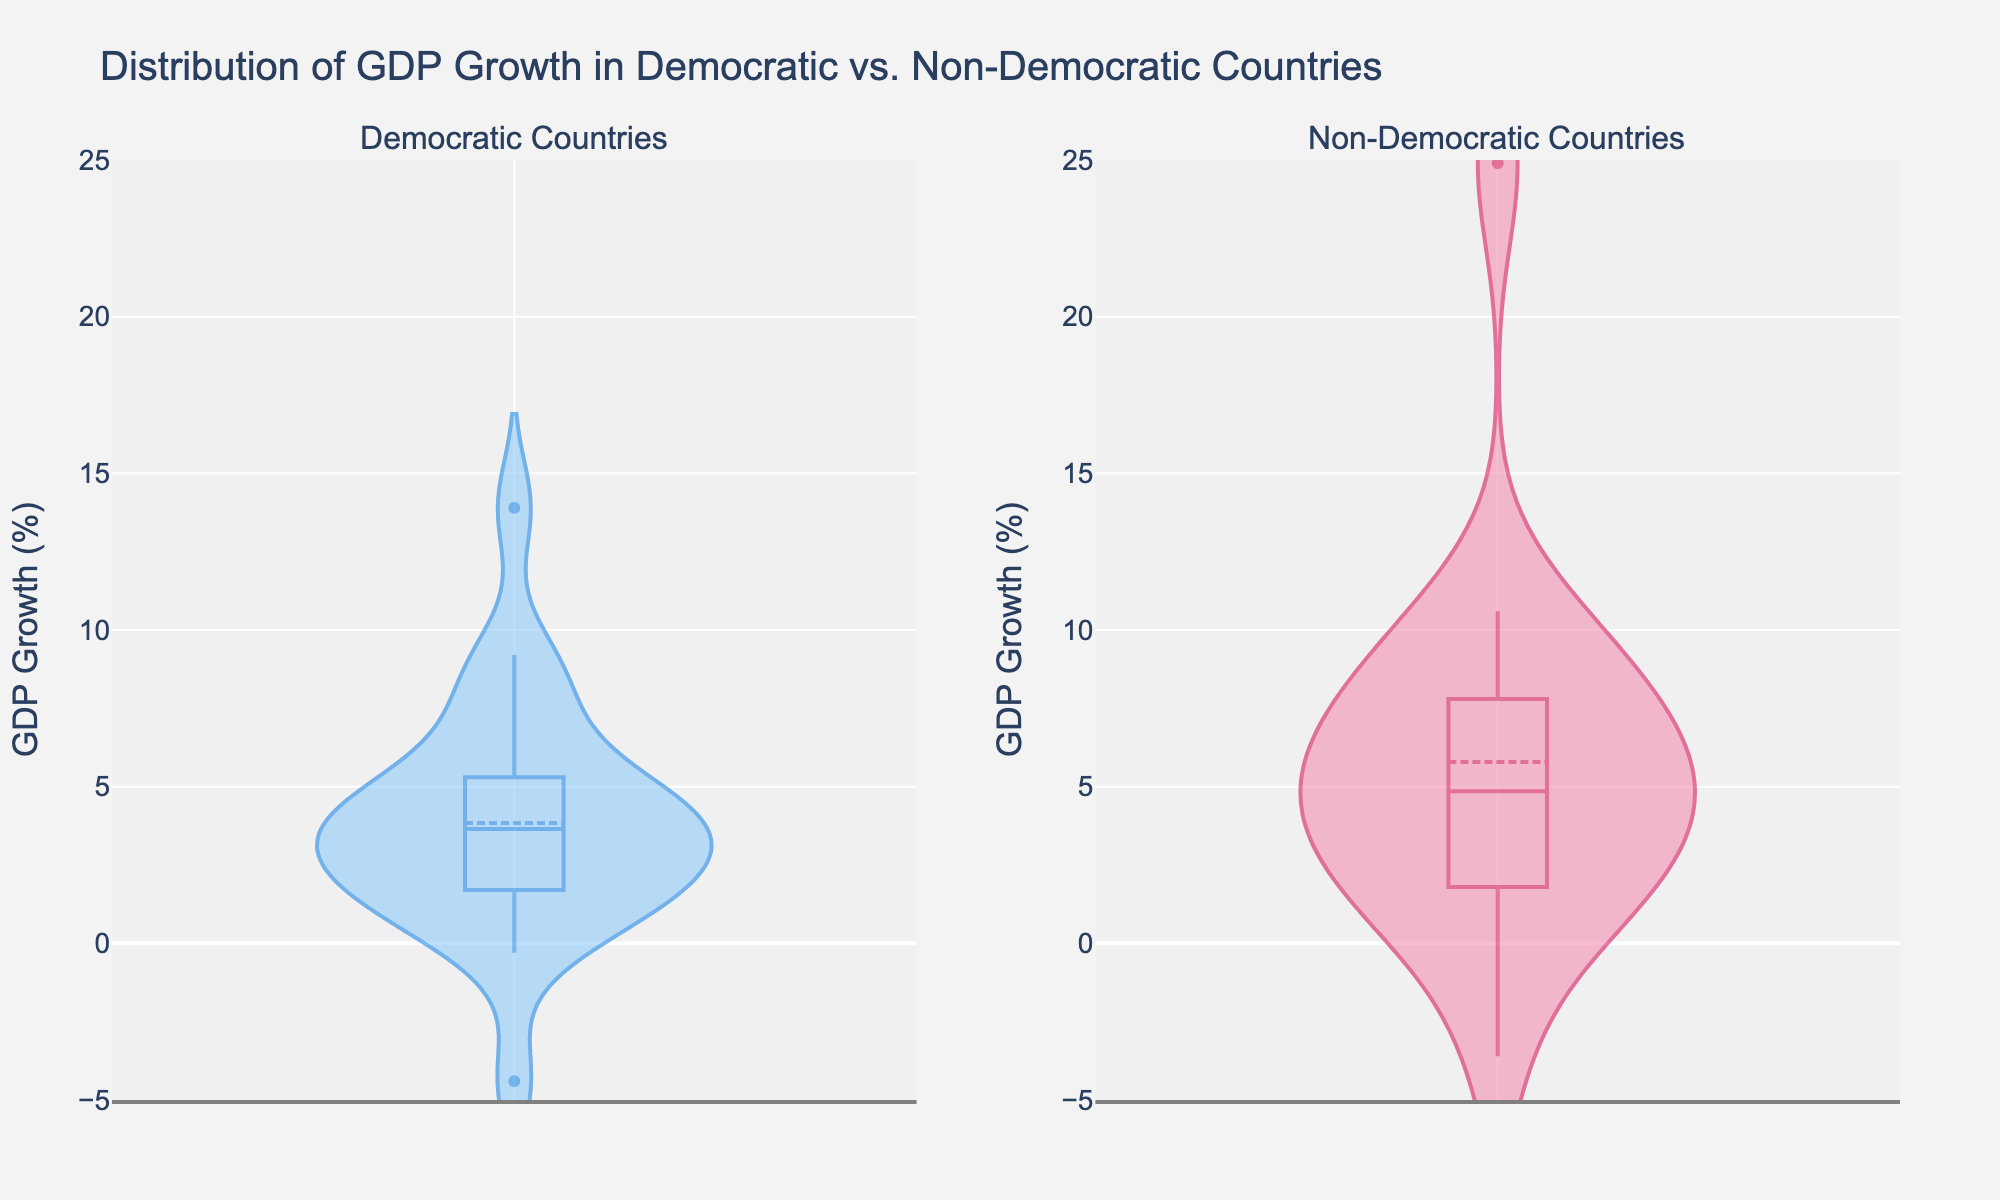What is the title of the plot? The title is displayed at the top of the plot in large font.
Answer: Distribution of GDP Growth in Democratic vs. Non-Democratic Countries Which subplot shows GDP growth for Non-Democratic countries? The subplot title on the right side indicates "Non-Democratic Countries".
Answer: The subplot on the right What is the y-axis range for the GDP growth? The y-axis range is given by the axis ticks, spanning from -5% to 25%.
Answer: -5% to 25% What is the median GDP growth for Democratic countries? The median line is visible in the Democratic countries' violin plot (the box shows the median line).
Answer: Between 2% and 3% Which group shows a wider spread of GDP growth values, Democratic or Non-Democratic countries? The spread is observed by the range and width of the violin plots, from min to max GDP growth.
Answer: Democratic countries What is the highest observed GDP growth in Non-Democratic countries? The tip of the violin plot for Non-Democratic countries reaches just above 24%.
Answer: Around 24.9% How does the mean GDP growth compare between Democratic and Non-Democratic countries? The mean line helps to compare and is visible in both subplots; it shows a slightly higher mean for Non-Democratic countries.
Answer: Higher in Non-Democratic countries Which subplot has a more proportionally concentrated distribution of GDP growth rates? Concentration is observed by the density bulge in the violin plots; Democratic countries seem more proportionally distributed.
Answer: Democratic countries How many distinct regions do the Democratic countries' GDP growth values cluster around? Clusters are shown by the concentration of denser areas in the violin plot.
Answer: Around 3 regions What is the approximate mean GDP growth for Non-Democratic countries, based on the violin plot? The mean line in the Non-Democratic subplot shows the approximate mean growth rate.
Answer: Around 6% 